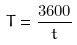<formula> <loc_0><loc_0><loc_500><loc_500>T = \frac { 3 6 0 0 } { t }</formula> 